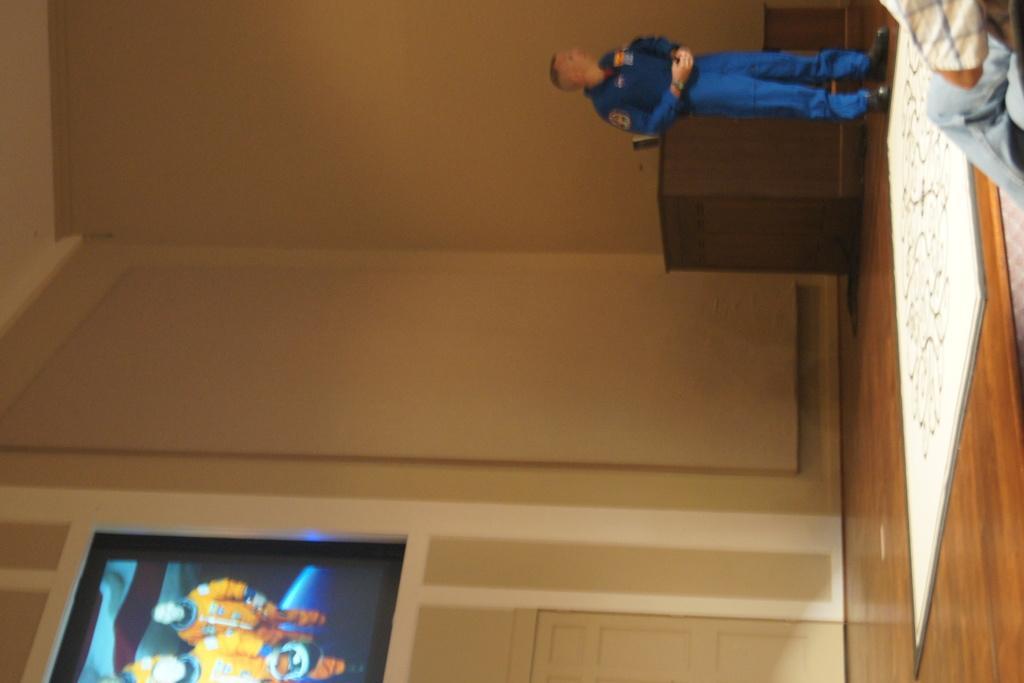Could you give a brief overview of what you see in this image? This is a horizontal image where we can see there is a table and person standing in front of that, beside that there is a photo frame on pole. 